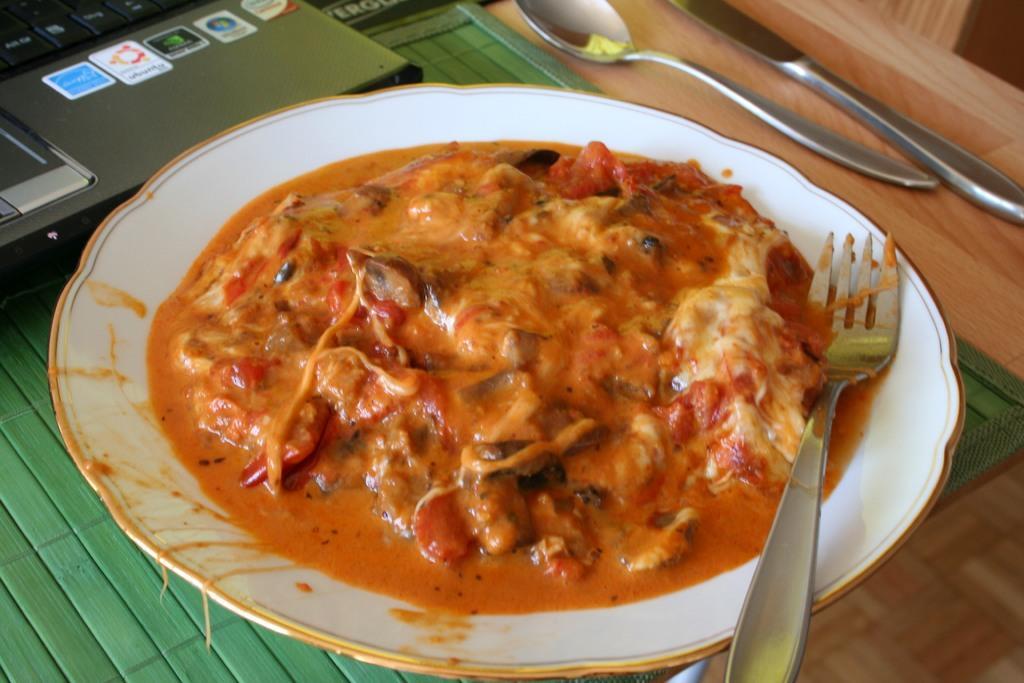How would you summarize this image in a sentence or two? There is a plate in the center of the image, there are food items and a fork in it, there is a spoon, it seems like a knife and a laptop on the table. 